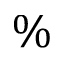<formula> <loc_0><loc_0><loc_500><loc_500>\%</formula> 